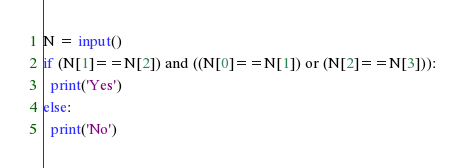<code> <loc_0><loc_0><loc_500><loc_500><_Python_>N = input()
if (N[1]==N[2]) and ((N[0]==N[1]) or (N[2]==N[3])):
  print('Yes')
else:
  print('No')</code> 